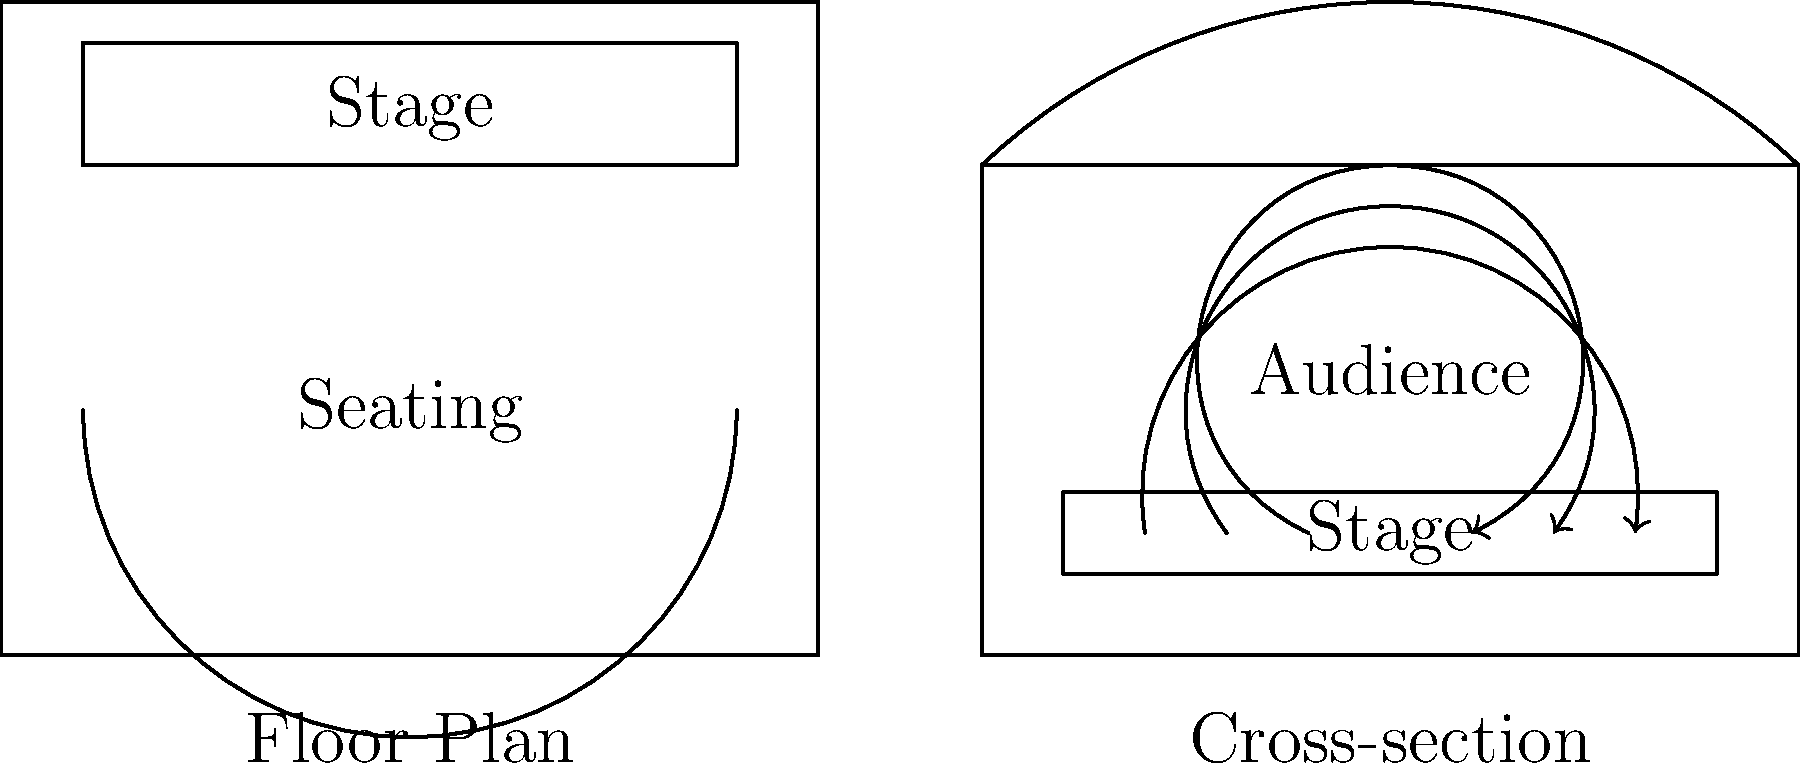Based on the floor plan and cross-section of this famous Italian theater, which architectural feature contributes most significantly to its renowned acoustics, and how does it enhance sound projection from the stage to the audience? To answer this question, we need to analyze the theater's design elements that affect acoustics:

1. Shape of the auditorium: The floor plan shows a horseshoe-shaped seating arrangement, typical of Italian opera houses. This shape helps reflect sound evenly throughout the audience.

2. Ceiling design: The cross-section reveals a domed or vaulted ceiling. This feature is crucial for sound reflection and distribution.

3. Stage configuration: The stage is slightly elevated and has a proscenium arch (implied by the cross-section), which helps project sound forward.

4. Materials: Though not explicitly shown, Italian theaters of this style often used wood and plaster, which have good acoustic properties.

5. Size and proportions: The theater appears to have a balanced ratio between width, length, and height, which is important for sound quality.

Among these features, the most significant contributor to the theater's renowned acoustics is likely the domed or vaulted ceiling. Here's why:

a) Sound reflection: The curved ceiling acts as a natural sound reflector, bouncing sound waves from the stage towards the audience.

b) Even distribution: The shape of the ceiling helps distribute sound evenly throughout the auditorium, reducing dead spots.

c) Amplification: The dome can act as a natural amplifier, slightly increasing the volume of sound reaching the audience.

d) Reverberation control: The curved surface helps control reverberation time, creating a warm, rich sound without excessive echo.

e) Complementary to other features: The ceiling works in conjunction with the horseshoe shape and stage design to create optimal acoustics.

The sound waves illustrated in the cross-section demonstrate how the ceiling helps project and distribute sound from the stage to various parts of the audience, enhancing the overall acoustic experience.
Answer: The domed/vaulted ceiling, which reflects and evenly distributes sound waves from the stage to the audience. 